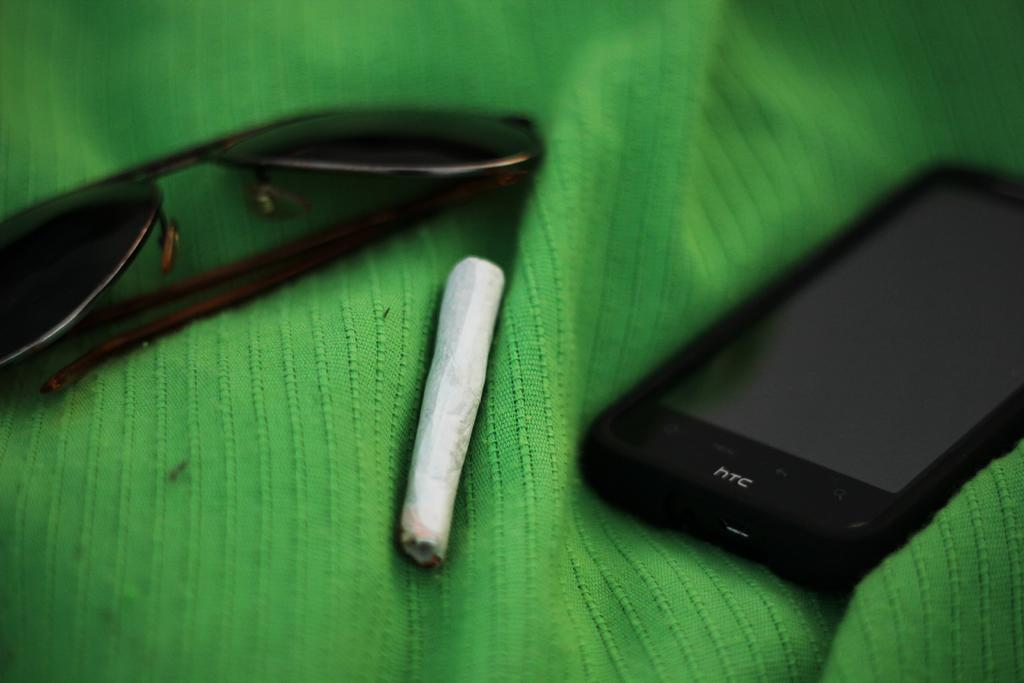<image>
Render a clear and concise summary of the photo. An HTC phone lies on a green blanket next to a cigarette and a pair of sunglasses. 